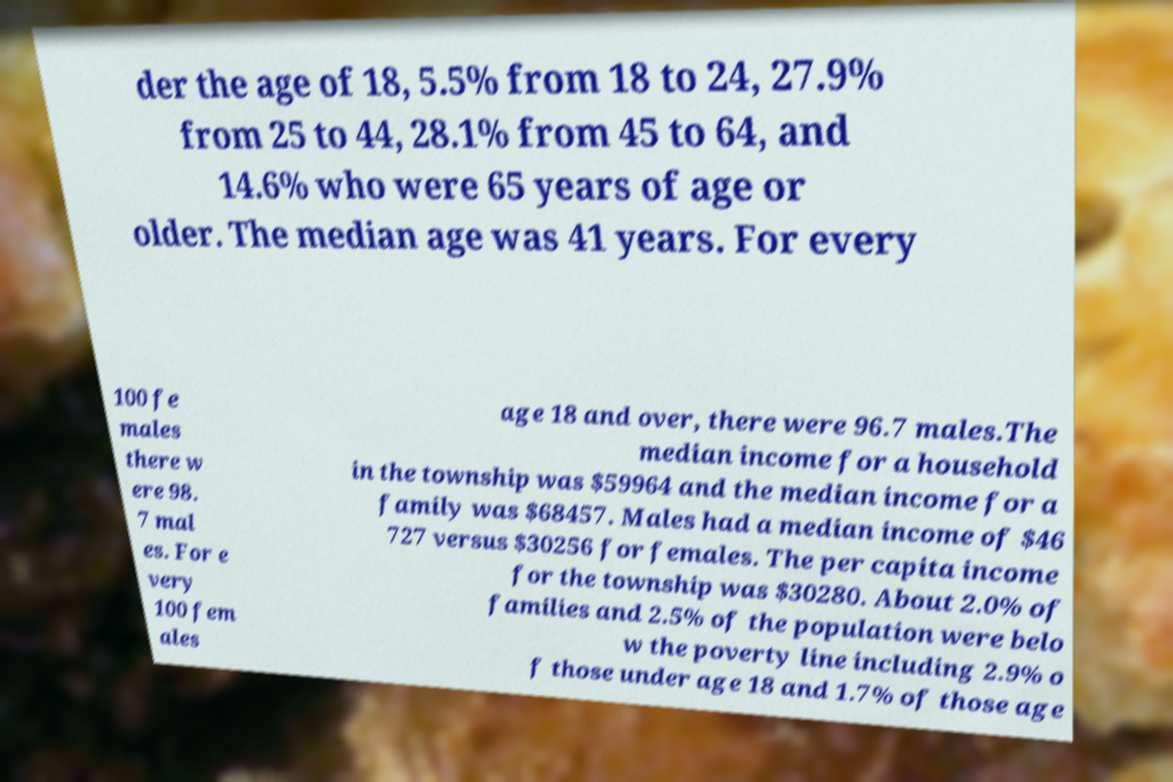Could you assist in decoding the text presented in this image and type it out clearly? der the age of 18, 5.5% from 18 to 24, 27.9% from 25 to 44, 28.1% from 45 to 64, and 14.6% who were 65 years of age or older. The median age was 41 years. For every 100 fe males there w ere 98. 7 mal es. For e very 100 fem ales age 18 and over, there were 96.7 males.The median income for a household in the township was $59964 and the median income for a family was $68457. Males had a median income of $46 727 versus $30256 for females. The per capita income for the township was $30280. About 2.0% of families and 2.5% of the population were belo w the poverty line including 2.9% o f those under age 18 and 1.7% of those age 